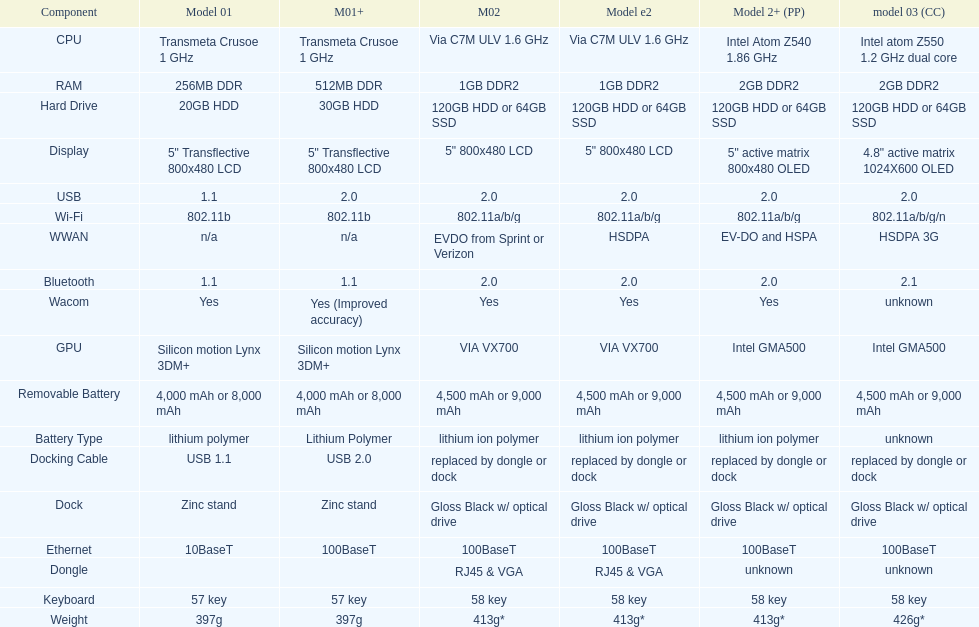The model 2 and the model 2e have what type of cpu? Via C7M ULV 1.6 GHz. 